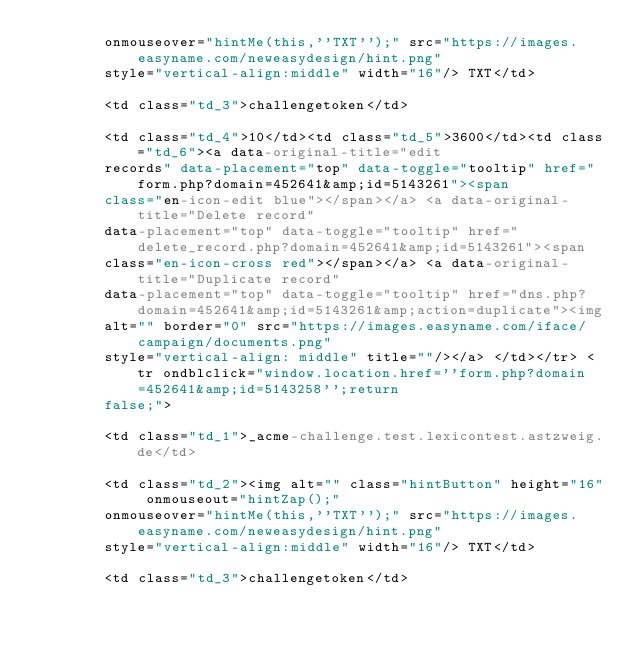<code> <loc_0><loc_0><loc_500><loc_500><_YAML_>        onmouseover="hintMe(this,''TXT'');" src="https://images.easyname.com/neweasydesign/hint.png"
        style="vertical-align:middle" width="16"/> TXT</td>

        <td class="td_3">challengetoken</td>

        <td class="td_4">10</td><td class="td_5">3600</td><td class="td_6"><a data-original-title="edit
        records" data-placement="top" data-toggle="tooltip" href="form.php?domain=452641&amp;id=5143261"><span
        class="en-icon-edit blue"></span></a> <a data-original-title="Delete record"
        data-placement="top" data-toggle="tooltip" href="delete_record.php?domain=452641&amp;id=5143261"><span
        class="en-icon-cross red"></span></a> <a data-original-title="Duplicate record"
        data-placement="top" data-toggle="tooltip" href="dns.php?domain=452641&amp;id=5143261&amp;action=duplicate"><img
        alt="" border="0" src="https://images.easyname.com/iface/campaign/documents.png"
        style="vertical-align: middle" title=""/></a> </td></tr> <tr ondblclick="window.location.href=''form.php?domain=452641&amp;id=5143258'';return
        false;">

        <td class="td_1">_acme-challenge.test.lexicontest.astzweig.de</td>

        <td class="td_2"><img alt="" class="hintButton" height="16" onmouseout="hintZap();"
        onmouseover="hintMe(this,''TXT'');" src="https://images.easyname.com/neweasydesign/hint.png"
        style="vertical-align:middle" width="16"/> TXT</td>

        <td class="td_3">challengetoken</td>
</code> 